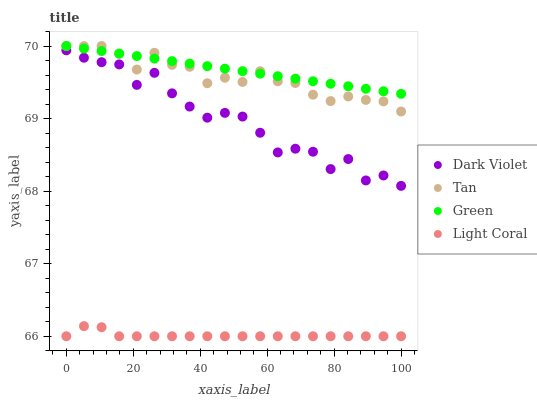Does Light Coral have the minimum area under the curve?
Answer yes or no. Yes. Does Green have the maximum area under the curve?
Answer yes or no. Yes. Does Tan have the minimum area under the curve?
Answer yes or no. No. Does Tan have the maximum area under the curve?
Answer yes or no. No. Is Green the smoothest?
Answer yes or no. Yes. Is Dark Violet the roughest?
Answer yes or no. Yes. Is Tan the smoothest?
Answer yes or no. No. Is Tan the roughest?
Answer yes or no. No. Does Light Coral have the lowest value?
Answer yes or no. Yes. Does Tan have the lowest value?
Answer yes or no. No. Does Green have the highest value?
Answer yes or no. Yes. Does Dark Violet have the highest value?
Answer yes or no. No. Is Light Coral less than Dark Violet?
Answer yes or no. Yes. Is Green greater than Dark Violet?
Answer yes or no. Yes. Does Tan intersect Green?
Answer yes or no. Yes. Is Tan less than Green?
Answer yes or no. No. Is Tan greater than Green?
Answer yes or no. No. Does Light Coral intersect Dark Violet?
Answer yes or no. No. 